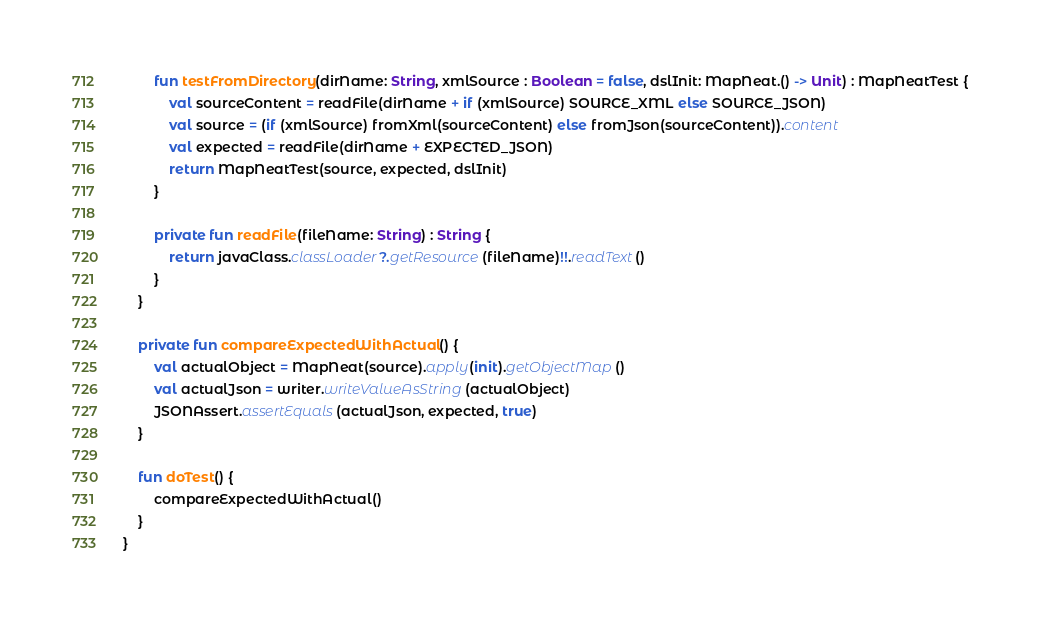<code> <loc_0><loc_0><loc_500><loc_500><_Kotlin_>        fun testFromDirectory(dirName: String, xmlSource : Boolean = false, dslInit: MapNeat.() -> Unit) : MapNeatTest {
            val sourceContent = readFile(dirName + if (xmlSource) SOURCE_XML else SOURCE_JSON)
            val source = (if (xmlSource) fromXml(sourceContent) else fromJson(sourceContent)).content
            val expected = readFile(dirName + EXPECTED_JSON)
            return MapNeatTest(source, expected, dslInit)
        }

        private fun readFile(fileName: String) : String {
            return javaClass.classLoader?.getResource(fileName)!!.readText()
        }
    }

    private fun compareExpectedWithActual() {
        val actualObject = MapNeat(source).apply(init).getObjectMap()
        val actualJson = writer.writeValueAsString(actualObject)
        JSONAssert.assertEquals(actualJson, expected, true)
    }

    fun doTest() {
        compareExpectedWithActual()
    }
}
</code> 